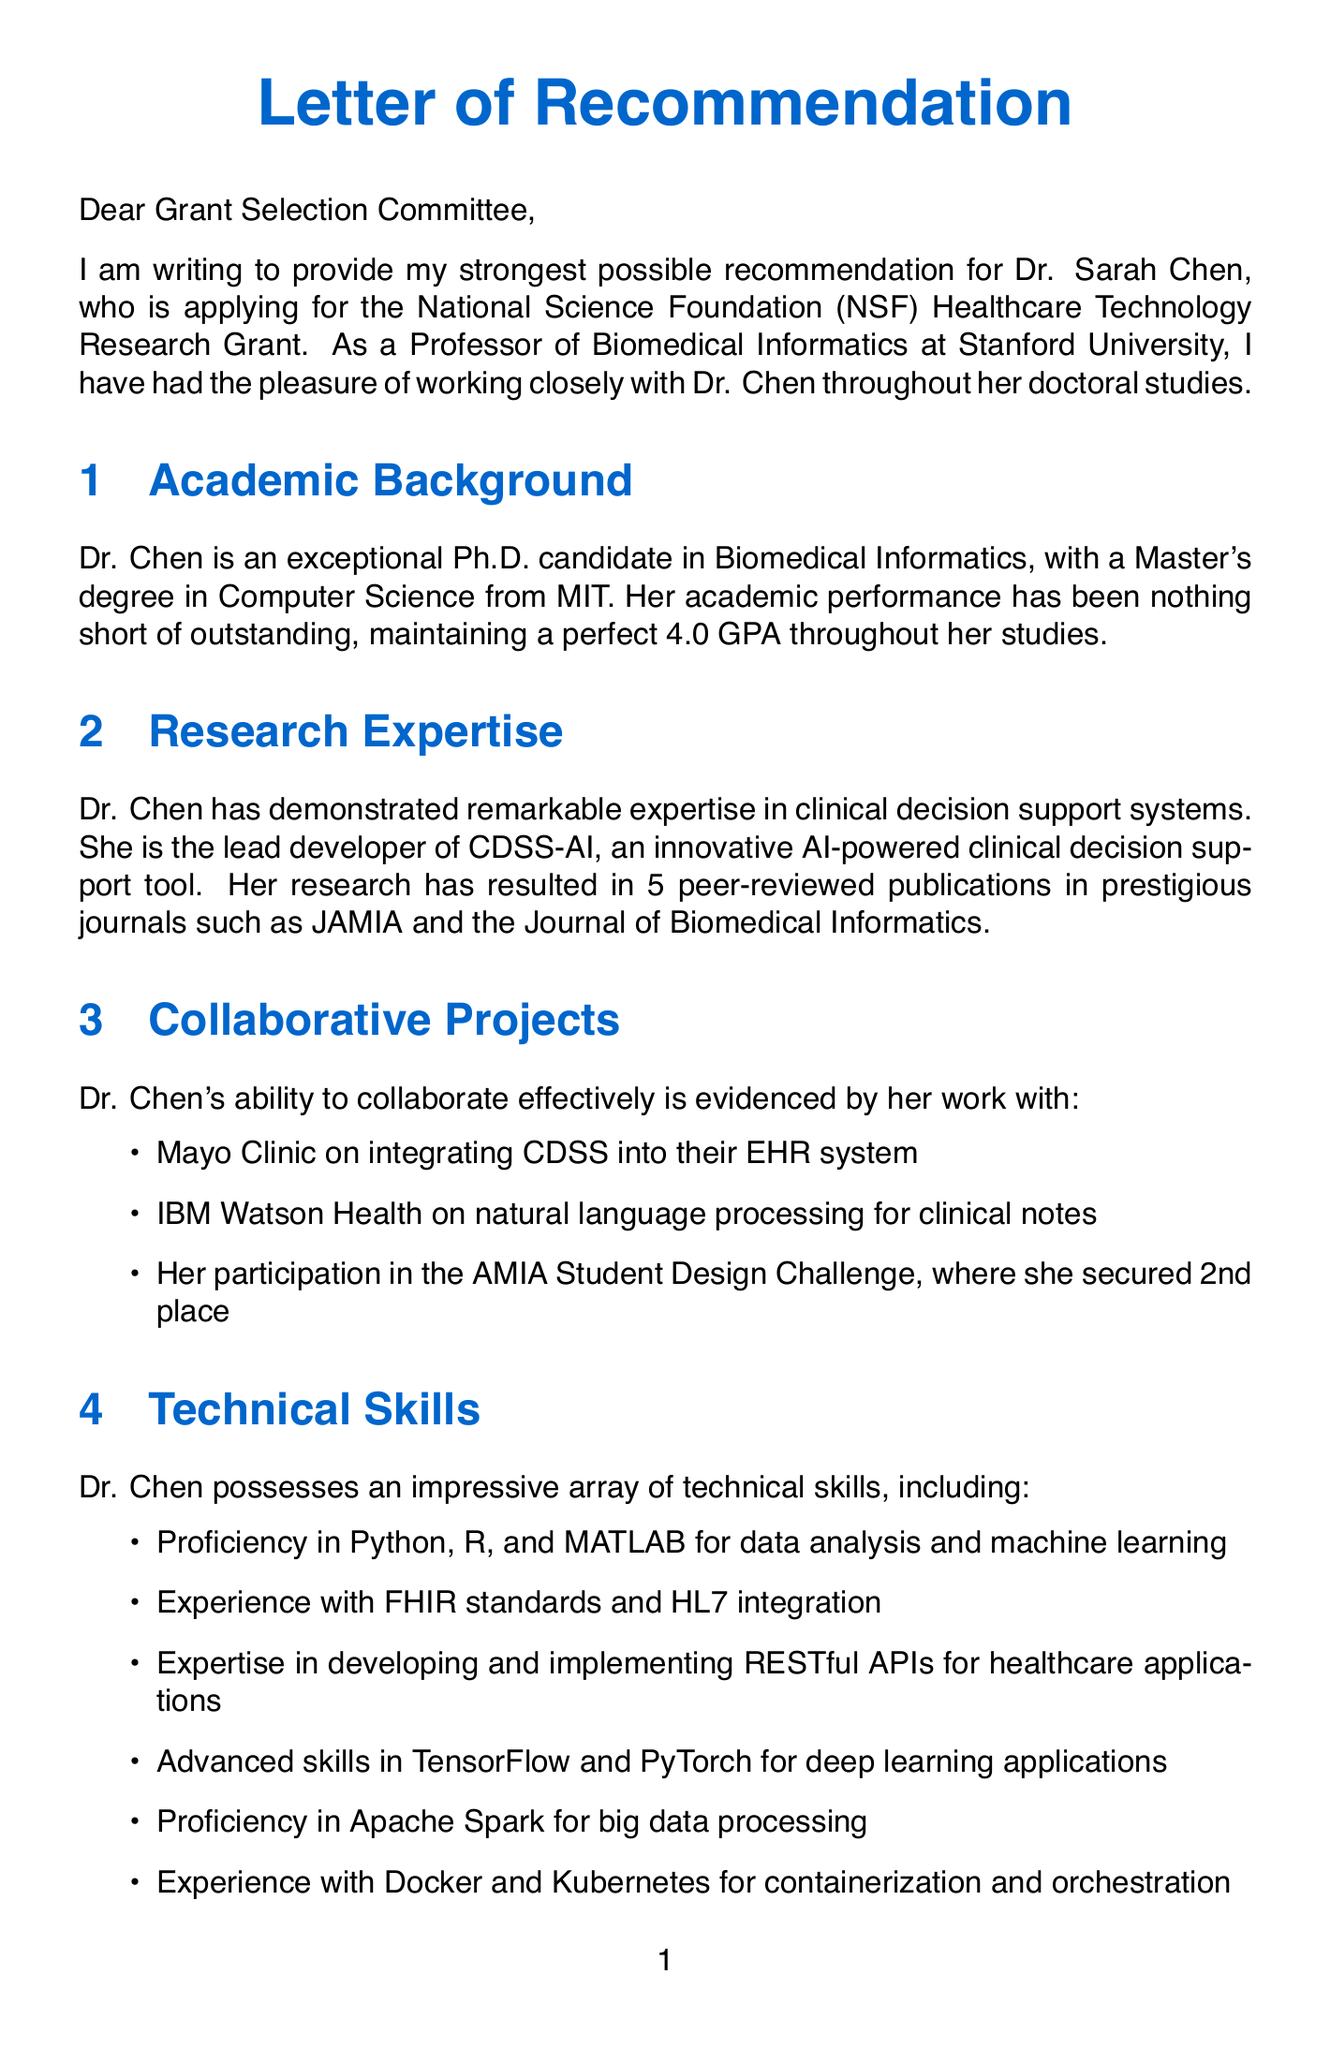What is the candidate's name? The candidate's name is explicitly stated in the introduction of the letter.
Answer: Dr. Sarah Chen Who is the professor writing the recommendation? The professor's name is mentioned at the beginning of the letter as the recommender.
Answer: Dr. Michael Johnson What is the candidate's GPA? The academic performance details include the candidate's GPA.
Answer: 4.0 GPA What is the main specialization of the candidate? The letter highlights the candidate's research expertise in a specific area.
Answer: Clinical decision support systems How many peer-reviewed articles has the candidate published? The body of the letter states the number of peer-reviewed articles by the candidate.
Answer: 5 What did the candidate secure in the AMIA Student Design Challenge? The document mentions the outcome of the candidate's participation in a specific event.
Answer: 2nd place Which standards has the candidate had experience with? The letter lists specific technical standards that the candidate is proficient in.
Answer: FHIR standards What notable award did the candidate receive? The letter includes information about a specific award received by the candidate.
Answer: AMIA Doctoral Dissertation Award 